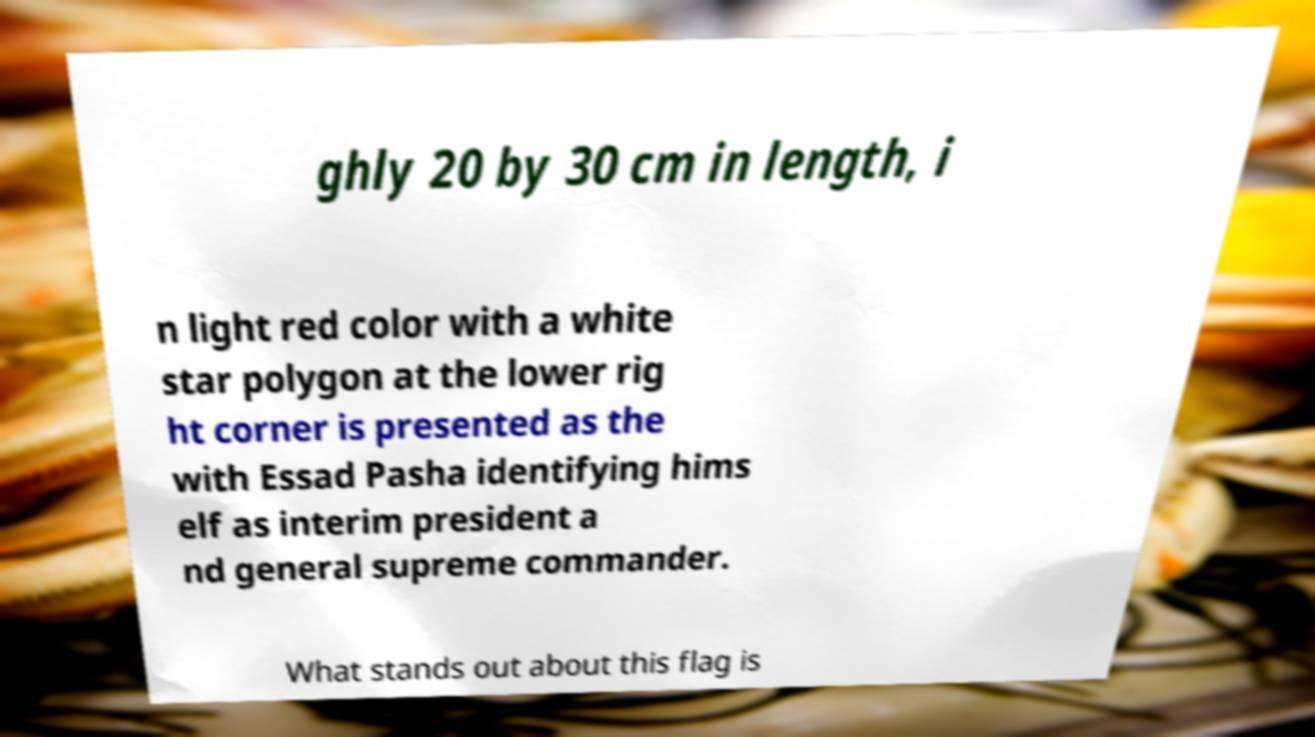Can you accurately transcribe the text from the provided image for me? ghly 20 by 30 cm in length, i n light red color with a white star polygon at the lower rig ht corner is presented as the with Essad Pasha identifying hims elf as interim president a nd general supreme commander. What stands out about this flag is 